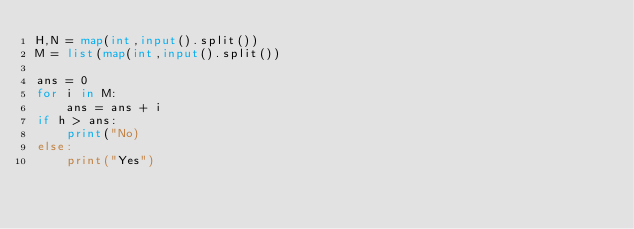Convert code to text. <code><loc_0><loc_0><loc_500><loc_500><_Python_>H,N = map(int,input().split())
M = list(map(int,input().split())

ans = 0       
for i in M:
    ans = ans + i
if h > ans:
    print("No)
else:
    print("Yes")
         </code> 